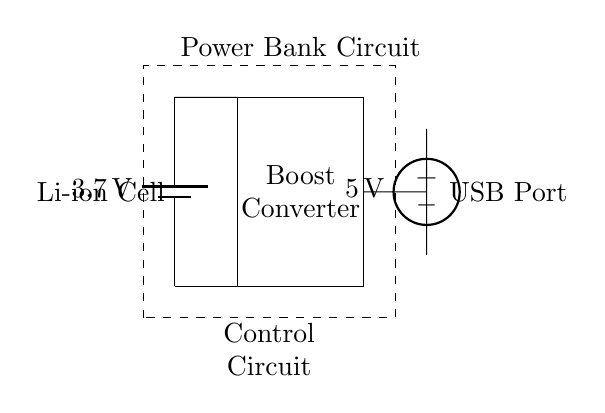What is the type of battery used in this circuit? The circuit diagram shows a "Li-ion Cell" labeled next to the battery symbol, indicating the type of battery used.
Answer: Li-ion Cell What is the output voltage of the boost converter? The boost converter is connected to a USB port labeled as having an output of "5 V", which indicates the expected voltage after boosting from the battery's voltage.
Answer: 5 V How many main components are visible in the circuit? The primary components seen in the circuit diagram include a battery, a boost converter, a USB port, and a control circuit, totaling four main parts.
Answer: Four What function does the boost converter serve in this circuit? The boost converter's function is to increase the voltage from the Li-ion cell (3.7 V) to the required USB output voltage (5 V) needed to charge devices.
Answer: Increase voltage Where is the control circuit located in the diagram? The control circuit is represented by a dashed rectangle surrounding the boost converter, battery, and USB port; it is positioned at the bottom of the circuit layout.
Answer: Bottom of the circuit Why is the control circuit important in this power bank? The control circuit manages the operation of the power bank to ensure proper voltage conversion and safety during charging, protecting against issues like overcurrent or overheating.
Answer: Manages operation 